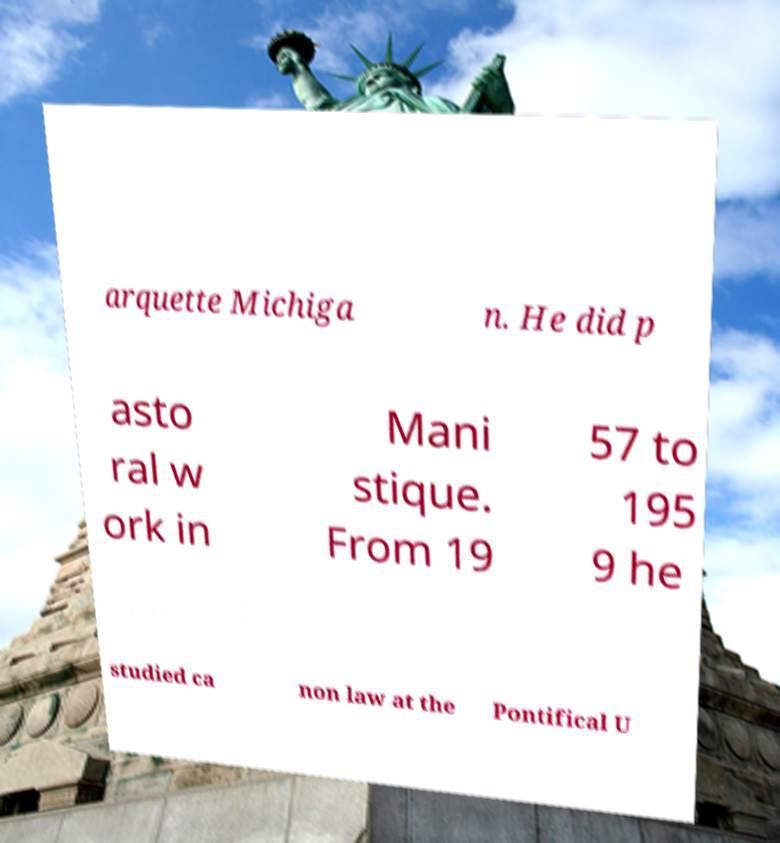What messages or text are displayed in this image? I need them in a readable, typed format. arquette Michiga n. He did p asto ral w ork in Mani stique. From 19 57 to 195 9 he studied ca non law at the Pontifical U 